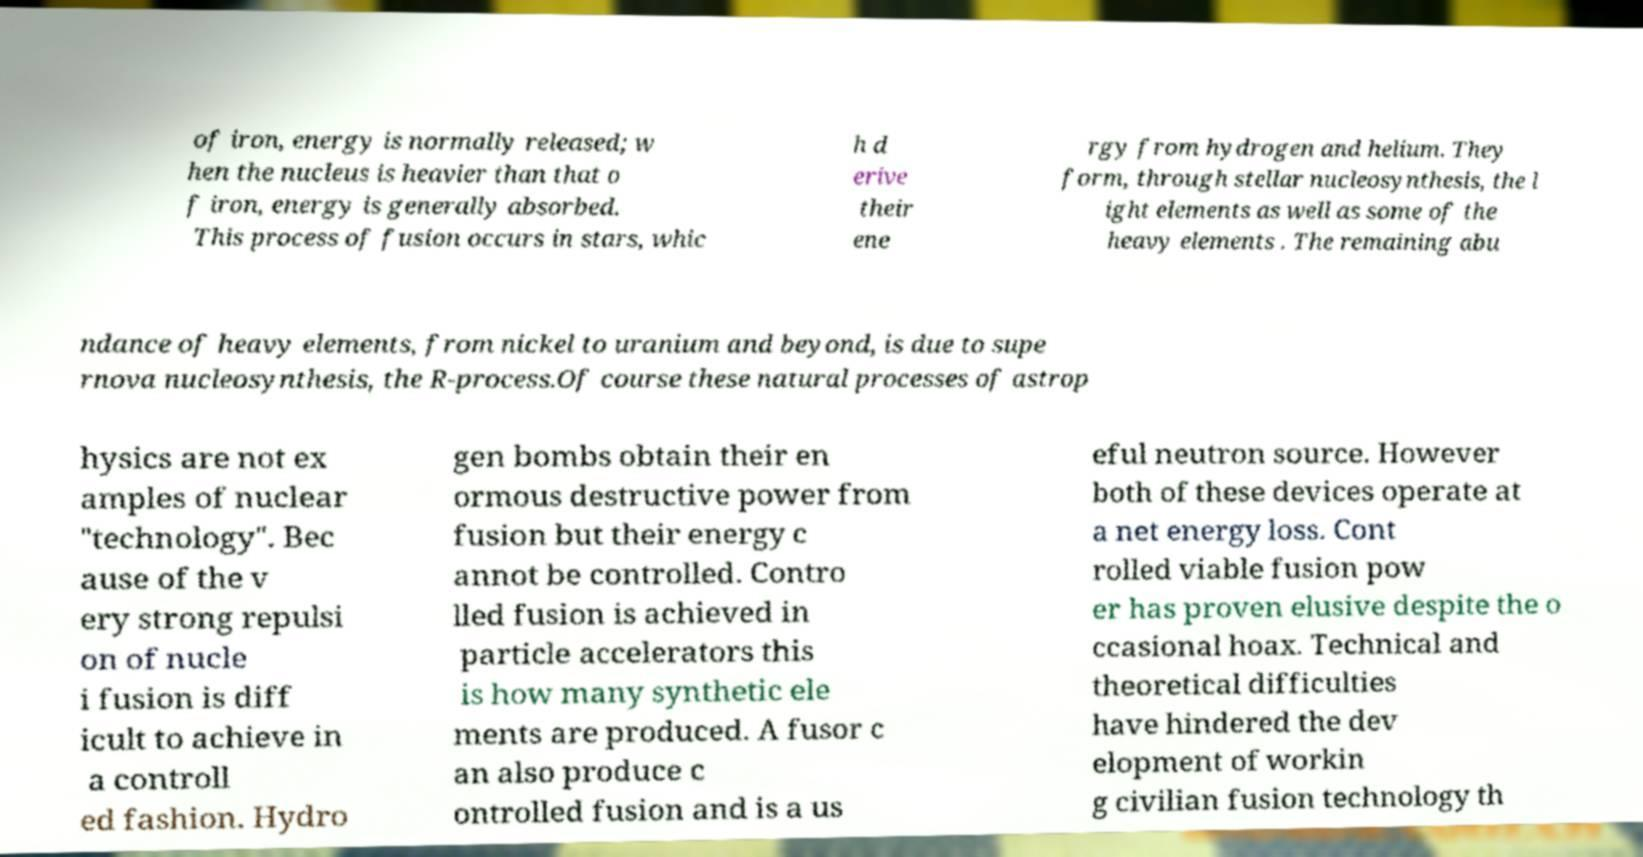Please identify and transcribe the text found in this image. of iron, energy is normally released; w hen the nucleus is heavier than that o f iron, energy is generally absorbed. This process of fusion occurs in stars, whic h d erive their ene rgy from hydrogen and helium. They form, through stellar nucleosynthesis, the l ight elements as well as some of the heavy elements . The remaining abu ndance of heavy elements, from nickel to uranium and beyond, is due to supe rnova nucleosynthesis, the R-process.Of course these natural processes of astrop hysics are not ex amples of nuclear "technology". Bec ause of the v ery strong repulsi on of nucle i fusion is diff icult to achieve in a controll ed fashion. Hydro gen bombs obtain their en ormous destructive power from fusion but their energy c annot be controlled. Contro lled fusion is achieved in particle accelerators this is how many synthetic ele ments are produced. A fusor c an also produce c ontrolled fusion and is a us eful neutron source. However both of these devices operate at a net energy loss. Cont rolled viable fusion pow er has proven elusive despite the o ccasional hoax. Technical and theoretical difficulties have hindered the dev elopment of workin g civilian fusion technology th 